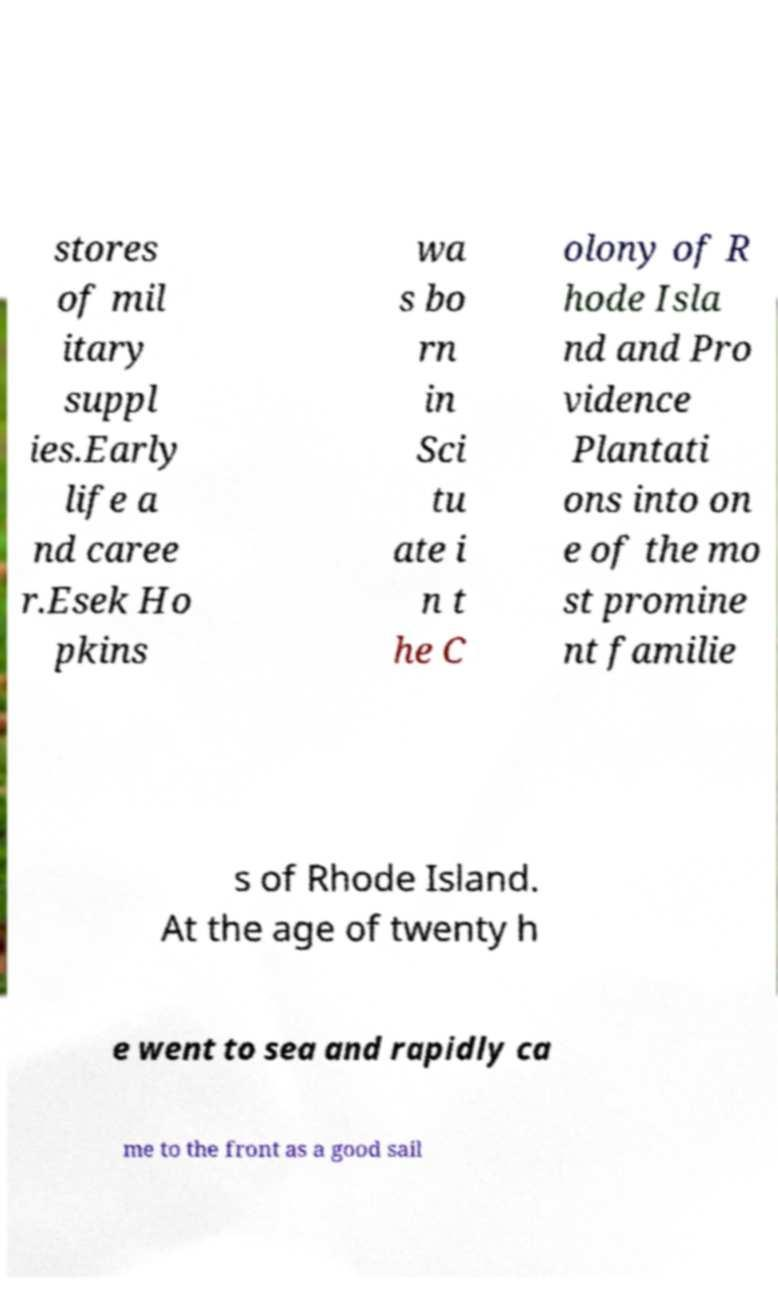Please identify and transcribe the text found in this image. stores of mil itary suppl ies.Early life a nd caree r.Esek Ho pkins wa s bo rn in Sci tu ate i n t he C olony of R hode Isla nd and Pro vidence Plantati ons into on e of the mo st promine nt familie s of Rhode Island. At the age of twenty h e went to sea and rapidly ca me to the front as a good sail 